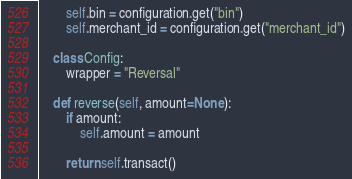Convert code to text. <code><loc_0><loc_0><loc_500><loc_500><_Python_>        self.bin = configuration.get("bin")
        self.merchant_id = configuration.get("merchant_id")

    class Config:
        wrapper = "Reversal"

    def reverse(self, amount=None):
        if amount:
            self.amount = amount

        return self.transact()
</code> 